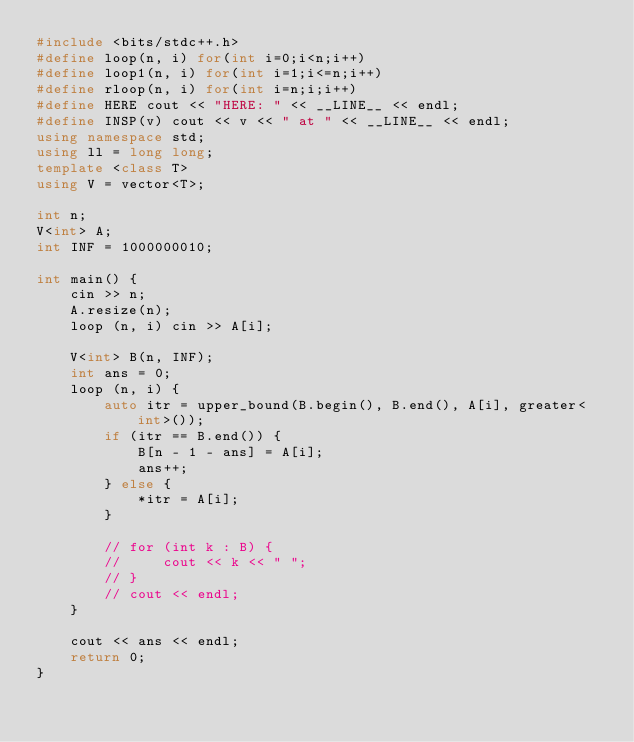<code> <loc_0><loc_0><loc_500><loc_500><_C++_>#include <bits/stdc++.h>
#define loop(n, i) for(int i=0;i<n;i++)
#define loop1(n, i) for(int i=1;i<=n;i++)
#define rloop(n, i) for(int i=n;i;i++)
#define HERE cout << "HERE: " << __LINE__ << endl;
#define INSP(v) cout << v << " at " << __LINE__ << endl;
using namespace std;
using ll = long long;
template <class T>
using V = vector<T>;

int n;
V<int> A;
int INF = 1000000010;

int main() {
    cin >> n;
    A.resize(n);
    loop (n, i) cin >> A[i];

    V<int> B(n, INF);
    int ans = 0;
    loop (n, i) {
        auto itr = upper_bound(B.begin(), B.end(), A[i], greater<int>());
        if (itr == B.end()) {
            B[n - 1 - ans] = A[i];
            ans++;
        } else {
            *itr = A[i];
        }

        // for (int k : B) {
        //     cout << k << " ";
        // }
        // cout << endl;
    }

    cout << ans << endl;
    return 0;
}

</code> 